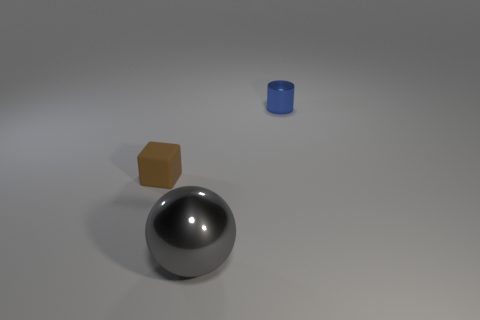Add 1 tiny brown cubes. How many objects exist? 4 Subtract all blocks. How many objects are left? 2 Add 1 things. How many things exist? 4 Subtract 0 cyan blocks. How many objects are left? 3 Subtract all gray metallic balls. Subtract all small blue metallic things. How many objects are left? 1 Add 1 large metallic balls. How many large metallic balls are left? 2 